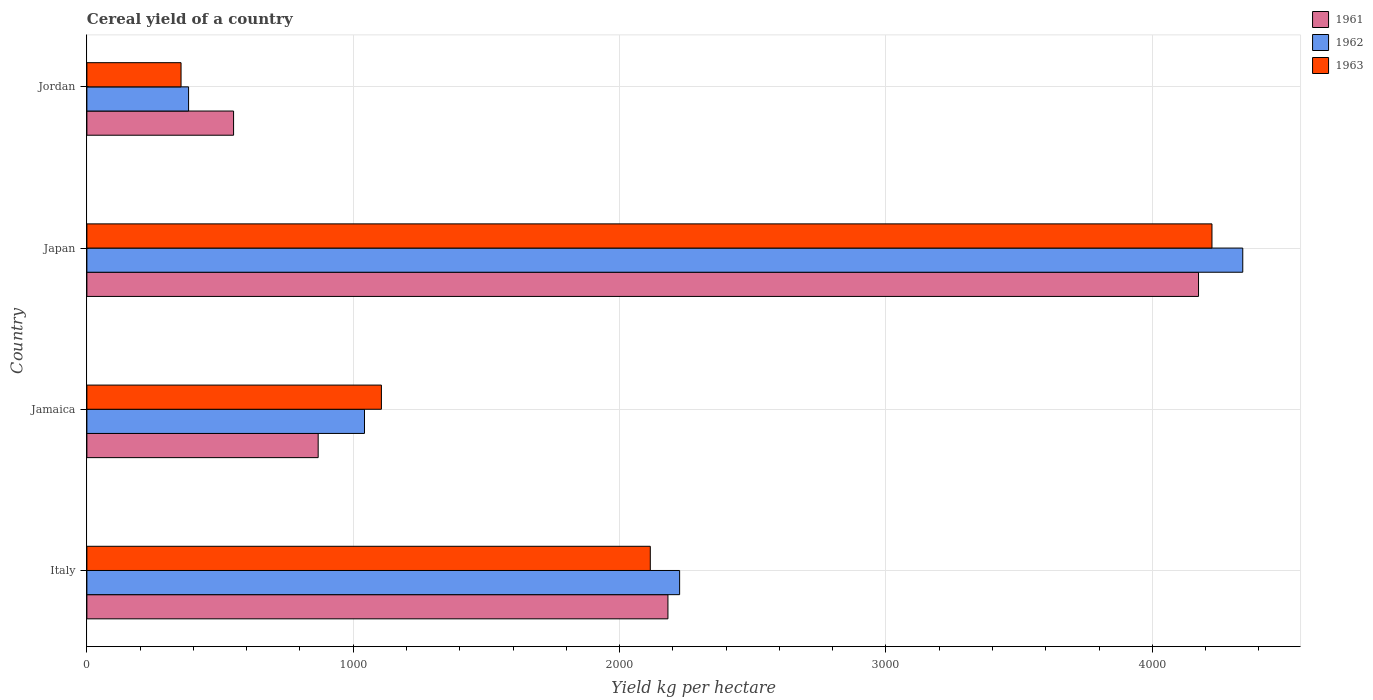How many different coloured bars are there?
Provide a succinct answer. 3. Are the number of bars per tick equal to the number of legend labels?
Offer a very short reply. Yes. What is the label of the 2nd group of bars from the top?
Your response must be concise. Japan. What is the total cereal yield in 1963 in Italy?
Offer a very short reply. 2115.2. Across all countries, what is the maximum total cereal yield in 1963?
Make the answer very short. 4223.95. Across all countries, what is the minimum total cereal yield in 1961?
Provide a succinct answer. 550.71. In which country was the total cereal yield in 1962 minimum?
Provide a short and direct response. Jordan. What is the total total cereal yield in 1962 in the graph?
Your response must be concise. 7988.82. What is the difference between the total cereal yield in 1962 in Japan and that in Jordan?
Make the answer very short. 3957.83. What is the difference between the total cereal yield in 1962 in Italy and the total cereal yield in 1961 in Jamaica?
Make the answer very short. 1357.03. What is the average total cereal yield in 1962 per country?
Your response must be concise. 1997.2. What is the difference between the total cereal yield in 1963 and total cereal yield in 1962 in Jamaica?
Give a very brief answer. 63.5. In how many countries, is the total cereal yield in 1961 greater than 3800 kg per hectare?
Offer a very short reply. 1. What is the ratio of the total cereal yield in 1962 in Italy to that in Japan?
Your answer should be very brief. 0.51. Is the total cereal yield in 1963 in Jamaica less than that in Jordan?
Give a very brief answer. No. Is the difference between the total cereal yield in 1963 in Japan and Jordan greater than the difference between the total cereal yield in 1962 in Japan and Jordan?
Your answer should be compact. No. What is the difference between the highest and the second highest total cereal yield in 1961?
Your response must be concise. 1992.06. What is the difference between the highest and the lowest total cereal yield in 1962?
Keep it short and to the point. 3957.83. How many bars are there?
Your answer should be very brief. 12. Does the graph contain grids?
Your response must be concise. Yes. Where does the legend appear in the graph?
Provide a short and direct response. Top right. What is the title of the graph?
Provide a succinct answer. Cereal yield of a country. What is the label or title of the X-axis?
Ensure brevity in your answer.  Yield kg per hectare. What is the label or title of the Y-axis?
Ensure brevity in your answer.  Country. What is the Yield kg per hectare of 1961 in Italy?
Offer a terse response. 2181.46. What is the Yield kg per hectare of 1962 in Italy?
Ensure brevity in your answer.  2225.34. What is the Yield kg per hectare in 1963 in Italy?
Ensure brevity in your answer.  2115.2. What is the Yield kg per hectare of 1961 in Jamaica?
Your response must be concise. 868.31. What is the Yield kg per hectare in 1962 in Jamaica?
Offer a very short reply. 1042.2. What is the Yield kg per hectare in 1963 in Jamaica?
Offer a very short reply. 1105.7. What is the Yield kg per hectare in 1961 in Japan?
Provide a short and direct response. 4173.51. What is the Yield kg per hectare in 1962 in Japan?
Offer a terse response. 4339.56. What is the Yield kg per hectare of 1963 in Japan?
Provide a short and direct response. 4223.95. What is the Yield kg per hectare in 1961 in Jordan?
Your answer should be very brief. 550.71. What is the Yield kg per hectare of 1962 in Jordan?
Keep it short and to the point. 381.73. What is the Yield kg per hectare in 1963 in Jordan?
Your answer should be very brief. 353.46. Across all countries, what is the maximum Yield kg per hectare in 1961?
Provide a succinct answer. 4173.51. Across all countries, what is the maximum Yield kg per hectare in 1962?
Keep it short and to the point. 4339.56. Across all countries, what is the maximum Yield kg per hectare of 1963?
Give a very brief answer. 4223.95. Across all countries, what is the minimum Yield kg per hectare of 1961?
Your response must be concise. 550.71. Across all countries, what is the minimum Yield kg per hectare of 1962?
Offer a very short reply. 381.73. Across all countries, what is the minimum Yield kg per hectare of 1963?
Offer a terse response. 353.46. What is the total Yield kg per hectare of 1961 in the graph?
Provide a short and direct response. 7773.98. What is the total Yield kg per hectare of 1962 in the graph?
Make the answer very short. 7988.82. What is the total Yield kg per hectare in 1963 in the graph?
Provide a short and direct response. 7798.31. What is the difference between the Yield kg per hectare in 1961 in Italy and that in Jamaica?
Your answer should be very brief. 1313.15. What is the difference between the Yield kg per hectare of 1962 in Italy and that in Jamaica?
Make the answer very short. 1183.14. What is the difference between the Yield kg per hectare in 1963 in Italy and that in Jamaica?
Your answer should be very brief. 1009.51. What is the difference between the Yield kg per hectare in 1961 in Italy and that in Japan?
Offer a terse response. -1992.06. What is the difference between the Yield kg per hectare in 1962 in Italy and that in Japan?
Keep it short and to the point. -2114.22. What is the difference between the Yield kg per hectare in 1963 in Italy and that in Japan?
Ensure brevity in your answer.  -2108.75. What is the difference between the Yield kg per hectare of 1961 in Italy and that in Jordan?
Provide a short and direct response. 1630.75. What is the difference between the Yield kg per hectare in 1962 in Italy and that in Jordan?
Your response must be concise. 1843.61. What is the difference between the Yield kg per hectare in 1963 in Italy and that in Jordan?
Keep it short and to the point. 1761.74. What is the difference between the Yield kg per hectare of 1961 in Jamaica and that in Japan?
Offer a very short reply. -3305.2. What is the difference between the Yield kg per hectare of 1962 in Jamaica and that in Japan?
Give a very brief answer. -3297.36. What is the difference between the Yield kg per hectare in 1963 in Jamaica and that in Japan?
Provide a short and direct response. -3118.26. What is the difference between the Yield kg per hectare of 1961 in Jamaica and that in Jordan?
Offer a terse response. 317.6. What is the difference between the Yield kg per hectare of 1962 in Jamaica and that in Jordan?
Provide a succinct answer. 660.47. What is the difference between the Yield kg per hectare of 1963 in Jamaica and that in Jordan?
Offer a terse response. 752.24. What is the difference between the Yield kg per hectare of 1961 in Japan and that in Jordan?
Give a very brief answer. 3622.8. What is the difference between the Yield kg per hectare in 1962 in Japan and that in Jordan?
Provide a succinct answer. 3957.82. What is the difference between the Yield kg per hectare in 1963 in Japan and that in Jordan?
Offer a terse response. 3870.49. What is the difference between the Yield kg per hectare of 1961 in Italy and the Yield kg per hectare of 1962 in Jamaica?
Offer a terse response. 1139.26. What is the difference between the Yield kg per hectare of 1961 in Italy and the Yield kg per hectare of 1963 in Jamaica?
Ensure brevity in your answer.  1075.76. What is the difference between the Yield kg per hectare in 1962 in Italy and the Yield kg per hectare in 1963 in Jamaica?
Make the answer very short. 1119.64. What is the difference between the Yield kg per hectare of 1961 in Italy and the Yield kg per hectare of 1962 in Japan?
Provide a short and direct response. -2158.1. What is the difference between the Yield kg per hectare of 1961 in Italy and the Yield kg per hectare of 1963 in Japan?
Keep it short and to the point. -2042.5. What is the difference between the Yield kg per hectare in 1962 in Italy and the Yield kg per hectare in 1963 in Japan?
Ensure brevity in your answer.  -1998.62. What is the difference between the Yield kg per hectare of 1961 in Italy and the Yield kg per hectare of 1962 in Jordan?
Your response must be concise. 1799.73. What is the difference between the Yield kg per hectare of 1961 in Italy and the Yield kg per hectare of 1963 in Jordan?
Offer a terse response. 1828. What is the difference between the Yield kg per hectare of 1962 in Italy and the Yield kg per hectare of 1963 in Jordan?
Your answer should be very brief. 1871.88. What is the difference between the Yield kg per hectare in 1961 in Jamaica and the Yield kg per hectare in 1962 in Japan?
Offer a terse response. -3471.25. What is the difference between the Yield kg per hectare in 1961 in Jamaica and the Yield kg per hectare in 1963 in Japan?
Make the answer very short. -3355.65. What is the difference between the Yield kg per hectare of 1962 in Jamaica and the Yield kg per hectare of 1963 in Japan?
Your answer should be very brief. -3181.76. What is the difference between the Yield kg per hectare in 1961 in Jamaica and the Yield kg per hectare in 1962 in Jordan?
Make the answer very short. 486.58. What is the difference between the Yield kg per hectare of 1961 in Jamaica and the Yield kg per hectare of 1963 in Jordan?
Offer a very short reply. 514.85. What is the difference between the Yield kg per hectare of 1962 in Jamaica and the Yield kg per hectare of 1963 in Jordan?
Your answer should be compact. 688.74. What is the difference between the Yield kg per hectare in 1961 in Japan and the Yield kg per hectare in 1962 in Jordan?
Make the answer very short. 3791.78. What is the difference between the Yield kg per hectare in 1961 in Japan and the Yield kg per hectare in 1963 in Jordan?
Make the answer very short. 3820.05. What is the difference between the Yield kg per hectare of 1962 in Japan and the Yield kg per hectare of 1963 in Jordan?
Give a very brief answer. 3986.1. What is the average Yield kg per hectare of 1961 per country?
Give a very brief answer. 1943.5. What is the average Yield kg per hectare in 1962 per country?
Keep it short and to the point. 1997.2. What is the average Yield kg per hectare of 1963 per country?
Provide a short and direct response. 1949.58. What is the difference between the Yield kg per hectare in 1961 and Yield kg per hectare in 1962 in Italy?
Give a very brief answer. -43.88. What is the difference between the Yield kg per hectare of 1961 and Yield kg per hectare of 1963 in Italy?
Offer a terse response. 66.25. What is the difference between the Yield kg per hectare of 1962 and Yield kg per hectare of 1963 in Italy?
Your answer should be very brief. 110.13. What is the difference between the Yield kg per hectare of 1961 and Yield kg per hectare of 1962 in Jamaica?
Ensure brevity in your answer.  -173.89. What is the difference between the Yield kg per hectare of 1961 and Yield kg per hectare of 1963 in Jamaica?
Provide a short and direct response. -237.39. What is the difference between the Yield kg per hectare of 1962 and Yield kg per hectare of 1963 in Jamaica?
Ensure brevity in your answer.  -63.5. What is the difference between the Yield kg per hectare in 1961 and Yield kg per hectare in 1962 in Japan?
Your answer should be compact. -166.04. What is the difference between the Yield kg per hectare in 1961 and Yield kg per hectare in 1963 in Japan?
Your response must be concise. -50.44. What is the difference between the Yield kg per hectare in 1962 and Yield kg per hectare in 1963 in Japan?
Give a very brief answer. 115.6. What is the difference between the Yield kg per hectare of 1961 and Yield kg per hectare of 1962 in Jordan?
Provide a succinct answer. 168.98. What is the difference between the Yield kg per hectare of 1961 and Yield kg per hectare of 1963 in Jordan?
Your response must be concise. 197.25. What is the difference between the Yield kg per hectare in 1962 and Yield kg per hectare in 1963 in Jordan?
Give a very brief answer. 28.27. What is the ratio of the Yield kg per hectare of 1961 in Italy to that in Jamaica?
Ensure brevity in your answer.  2.51. What is the ratio of the Yield kg per hectare in 1962 in Italy to that in Jamaica?
Provide a succinct answer. 2.14. What is the ratio of the Yield kg per hectare in 1963 in Italy to that in Jamaica?
Provide a succinct answer. 1.91. What is the ratio of the Yield kg per hectare of 1961 in Italy to that in Japan?
Keep it short and to the point. 0.52. What is the ratio of the Yield kg per hectare in 1962 in Italy to that in Japan?
Offer a very short reply. 0.51. What is the ratio of the Yield kg per hectare of 1963 in Italy to that in Japan?
Offer a terse response. 0.5. What is the ratio of the Yield kg per hectare of 1961 in Italy to that in Jordan?
Make the answer very short. 3.96. What is the ratio of the Yield kg per hectare in 1962 in Italy to that in Jordan?
Your answer should be very brief. 5.83. What is the ratio of the Yield kg per hectare in 1963 in Italy to that in Jordan?
Your response must be concise. 5.98. What is the ratio of the Yield kg per hectare of 1961 in Jamaica to that in Japan?
Make the answer very short. 0.21. What is the ratio of the Yield kg per hectare in 1962 in Jamaica to that in Japan?
Give a very brief answer. 0.24. What is the ratio of the Yield kg per hectare of 1963 in Jamaica to that in Japan?
Give a very brief answer. 0.26. What is the ratio of the Yield kg per hectare in 1961 in Jamaica to that in Jordan?
Offer a terse response. 1.58. What is the ratio of the Yield kg per hectare of 1962 in Jamaica to that in Jordan?
Provide a succinct answer. 2.73. What is the ratio of the Yield kg per hectare in 1963 in Jamaica to that in Jordan?
Ensure brevity in your answer.  3.13. What is the ratio of the Yield kg per hectare in 1961 in Japan to that in Jordan?
Provide a short and direct response. 7.58. What is the ratio of the Yield kg per hectare of 1962 in Japan to that in Jordan?
Give a very brief answer. 11.37. What is the ratio of the Yield kg per hectare of 1963 in Japan to that in Jordan?
Your answer should be compact. 11.95. What is the difference between the highest and the second highest Yield kg per hectare of 1961?
Your answer should be very brief. 1992.06. What is the difference between the highest and the second highest Yield kg per hectare in 1962?
Ensure brevity in your answer.  2114.22. What is the difference between the highest and the second highest Yield kg per hectare in 1963?
Your answer should be very brief. 2108.75. What is the difference between the highest and the lowest Yield kg per hectare in 1961?
Give a very brief answer. 3622.8. What is the difference between the highest and the lowest Yield kg per hectare of 1962?
Your answer should be very brief. 3957.82. What is the difference between the highest and the lowest Yield kg per hectare in 1963?
Provide a succinct answer. 3870.49. 